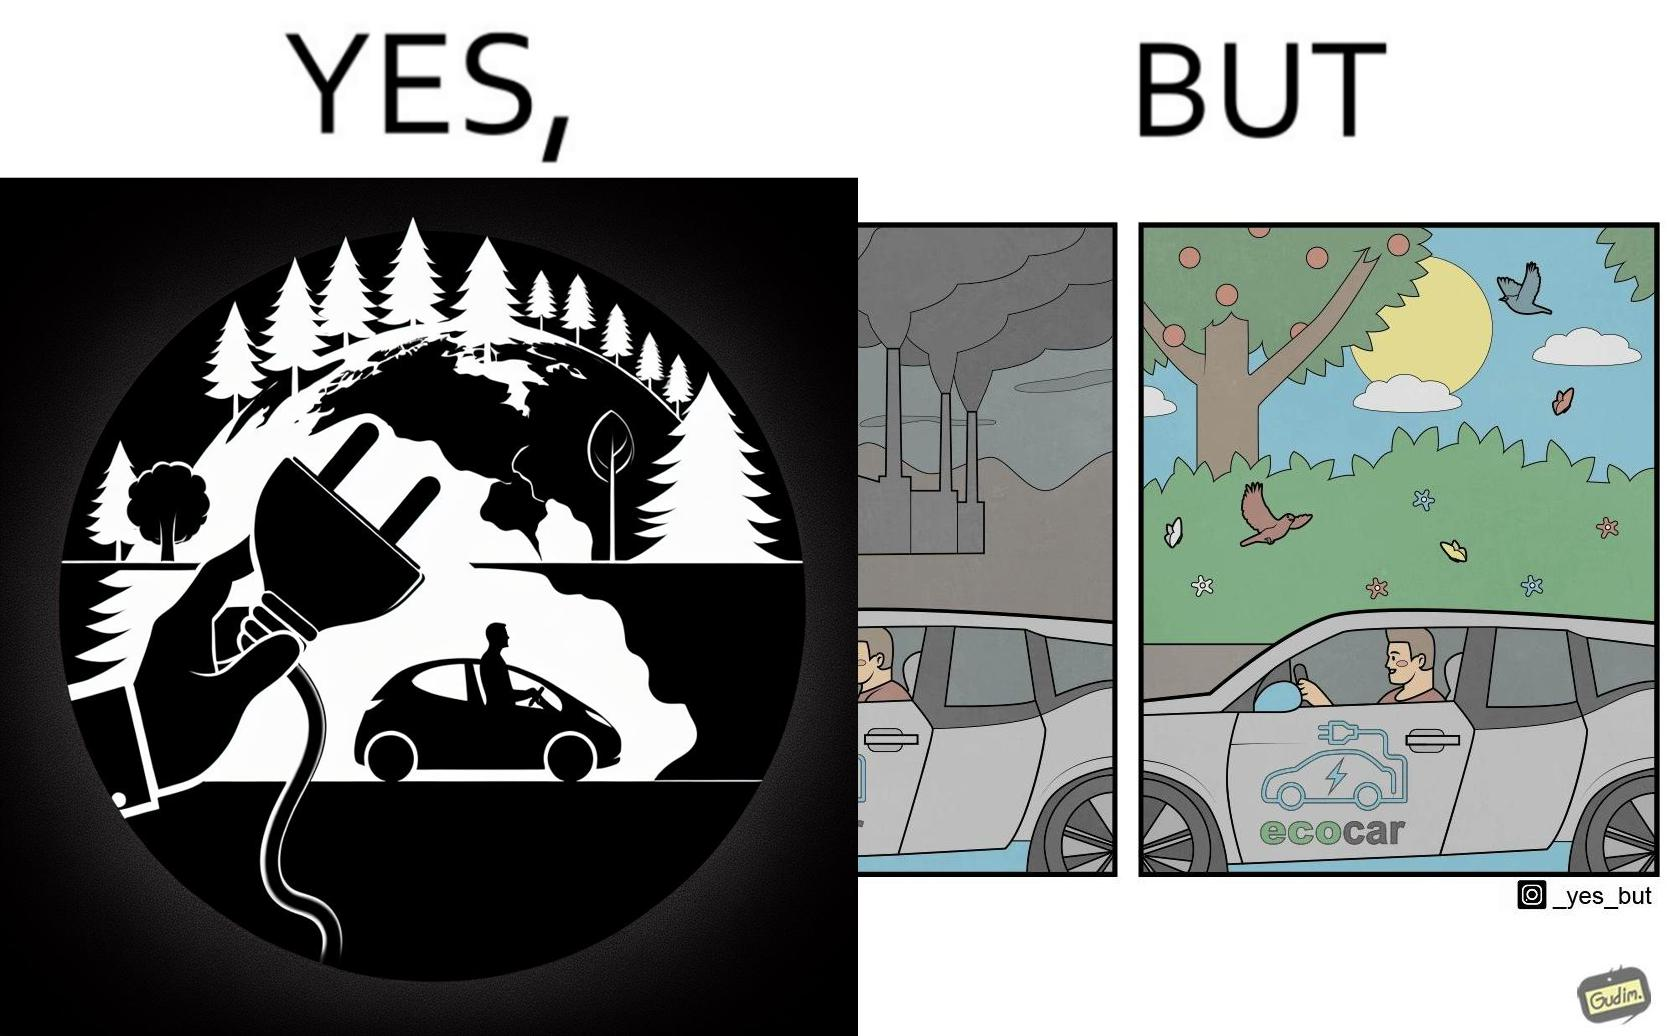Describe what you see in this image. The images are ironic since they show how even though electric powered cars are touted to be a game changer in the automotive industry and claims are made that they will make the world a greener and cleaner place to live in, the reality is quite different. Battery production causes vast amounts of pollution making such claims very doubtful 